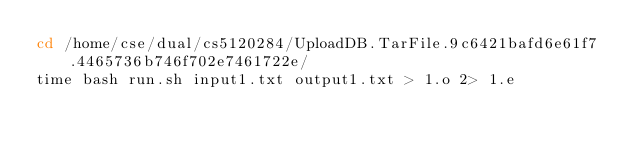Convert code to text. <code><loc_0><loc_0><loc_500><loc_500><_Bash_>cd /home/cse/dual/cs5120284/UploadDB.TarFile.9c6421bafd6e61f7.4465736b746f702e7461722e/
time bash run.sh input1.txt output1.txt > 1.o 2> 1.e
</code> 